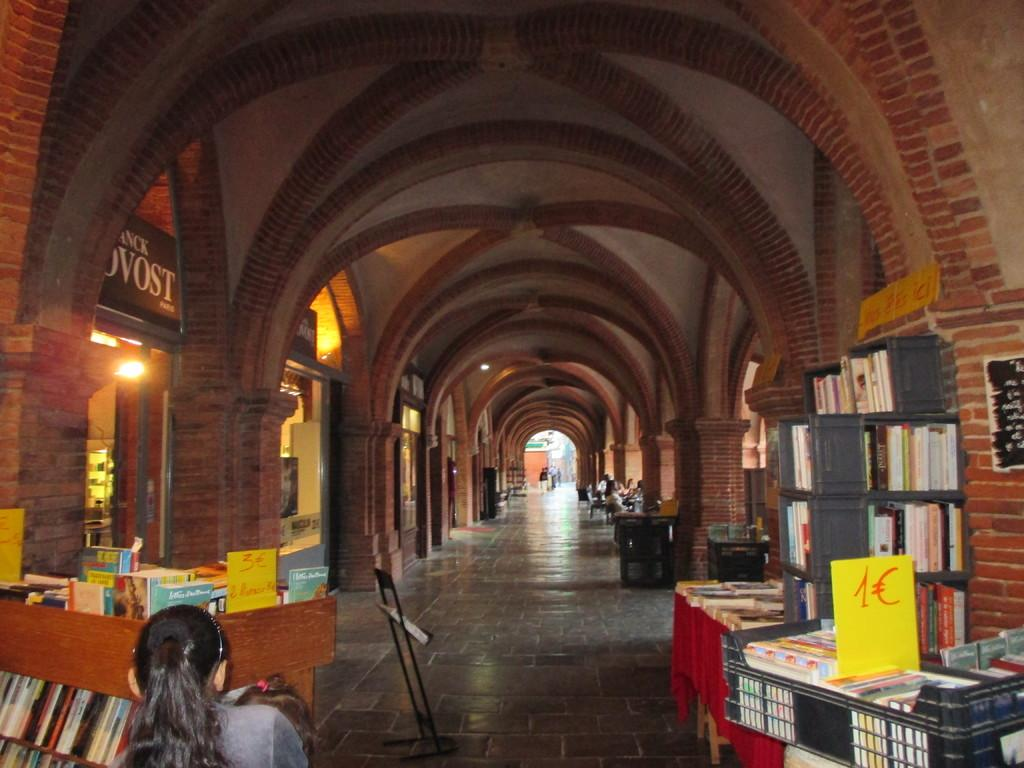<image>
Describe the image concisely. A book sale with  1C books on the right side. 